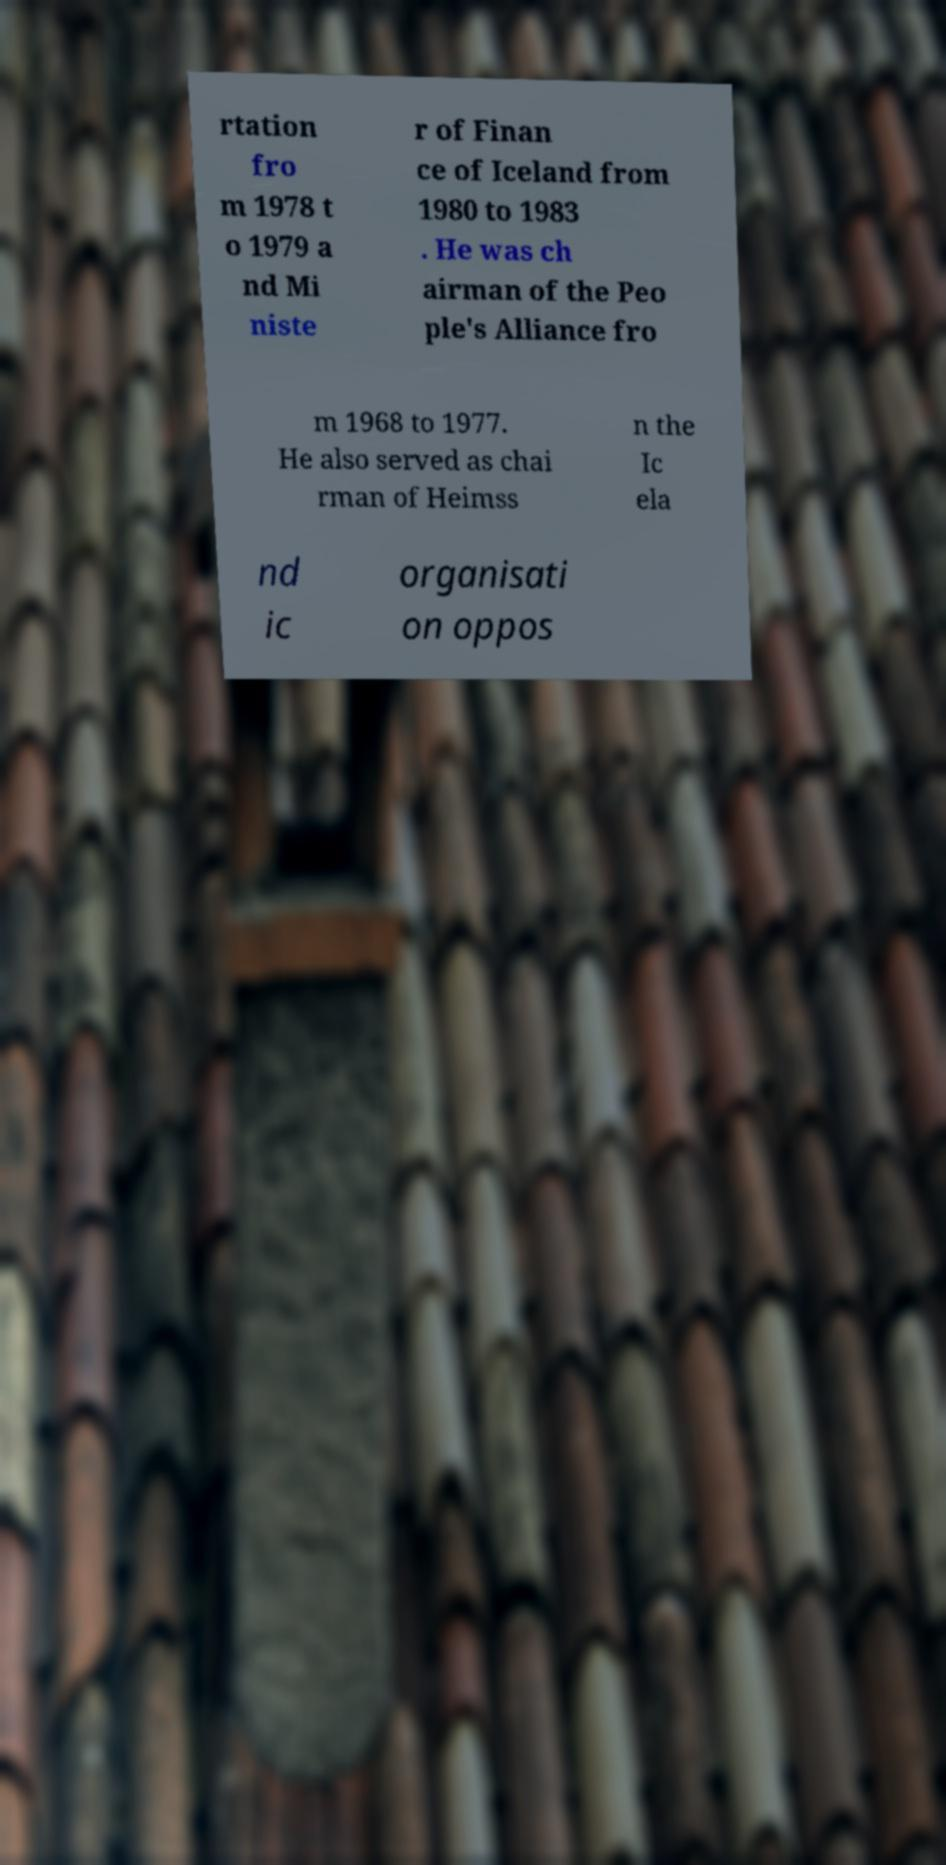There's text embedded in this image that I need extracted. Can you transcribe it verbatim? rtation fro m 1978 t o 1979 a nd Mi niste r of Finan ce of Iceland from 1980 to 1983 . He was ch airman of the Peo ple's Alliance fro m 1968 to 1977. He also served as chai rman of Heimss n the Ic ela nd ic organisati on oppos 